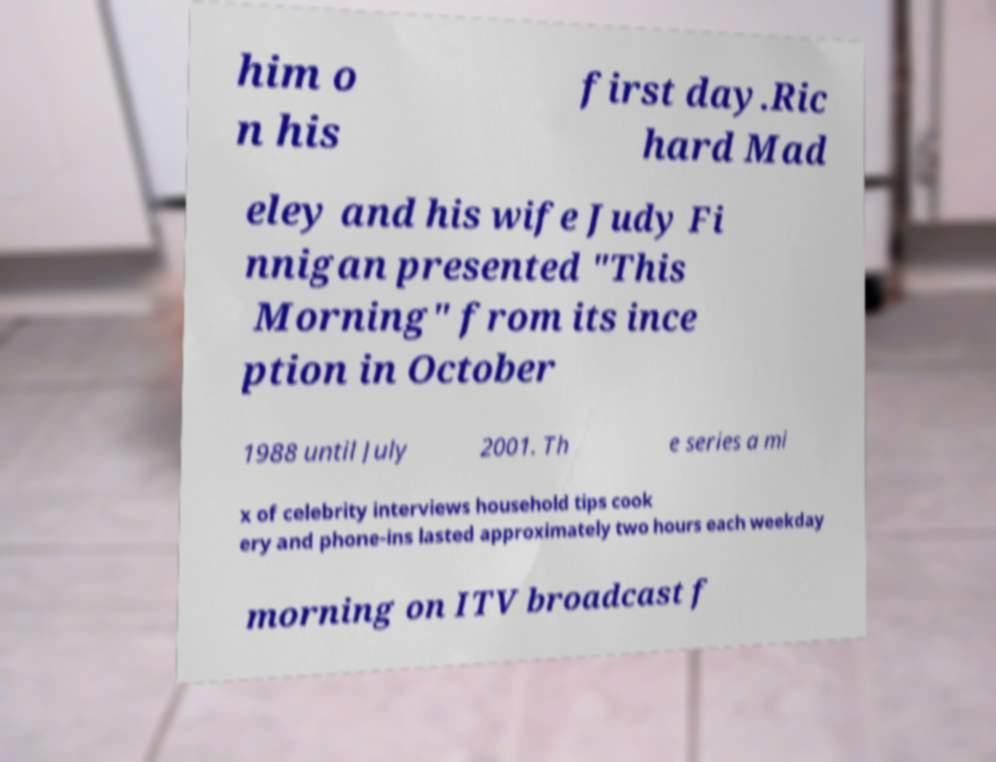What messages or text are displayed in this image? I need them in a readable, typed format. him o n his first day.Ric hard Mad eley and his wife Judy Fi nnigan presented "This Morning" from its ince ption in October 1988 until July 2001. Th e series a mi x of celebrity interviews household tips cook ery and phone-ins lasted approximately two hours each weekday morning on ITV broadcast f 